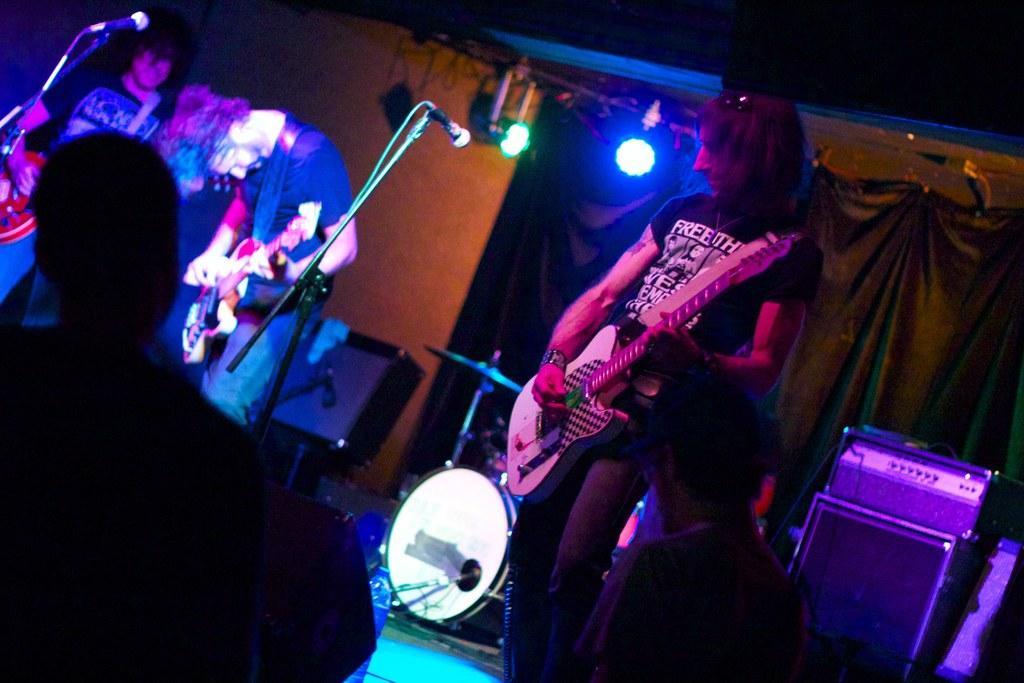How would you summarize this image in a sentence or two? In this image we can see persons playing guitars. There are mics with mic stands. In the back there are lights and curtains. And we can see another person. In the back there are drums and cymbal. And there are few other things. 